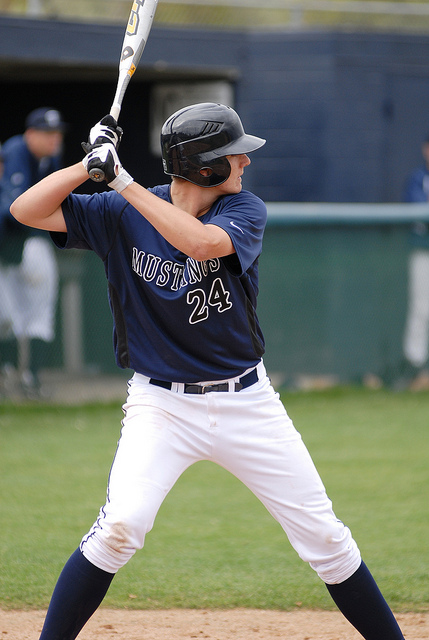<image>Who does he play for? I am not sure who he plays for. It could possibly be for the mustangs. Who does he play for? I am not sure who he plays for. It can be the Mustangs or Justine's. 